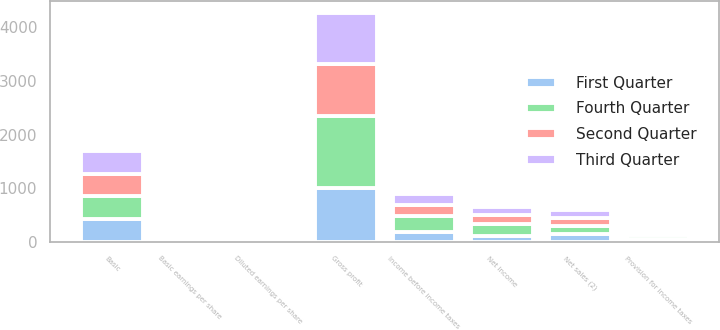Convert chart. <chart><loc_0><loc_0><loc_500><loc_500><stacked_bar_chart><ecel><fcel>Net sales (2)<fcel>Gross profit<fcel>Income before income taxes<fcel>Provision for income taxes<fcel>Net income<fcel>Basic earnings per share<fcel>Diluted earnings per share<fcel>Basic<nl><fcel>Fourth Quarter<fcel>150.5<fcel>1348<fcel>302<fcel>79<fcel>225<fcel>0.52<fcel>0.52<fcel>428<nl><fcel>First Quarter<fcel>150.5<fcel>999<fcel>182<fcel>59<fcel>118<fcel>0.28<fcel>0.27<fcel>427<nl><fcel>Second Quarter<fcel>150.5<fcel>967<fcel>208<fcel>46<fcel>158<fcel>0.38<fcel>0.37<fcel>420<nl><fcel>Third Quarter<fcel>150.5<fcel>956<fcel>207<fcel>62<fcel>143<fcel>0.34<fcel>0.34<fcel>417<nl></chart> 